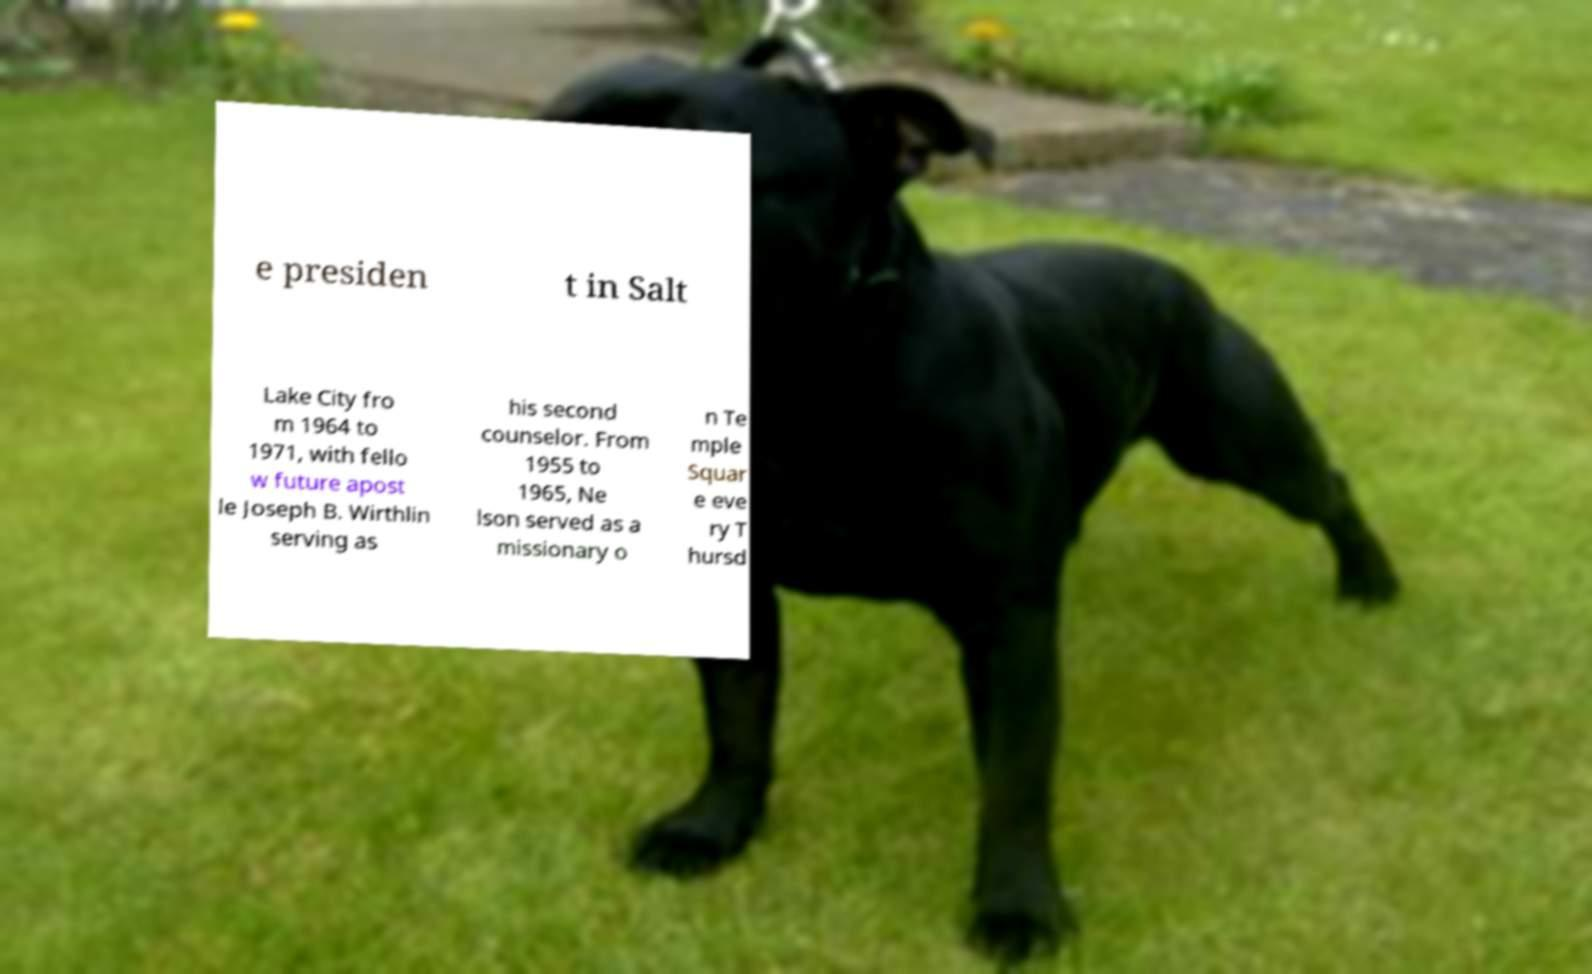What messages or text are displayed in this image? I need them in a readable, typed format. e presiden t in Salt Lake City fro m 1964 to 1971, with fello w future apost le Joseph B. Wirthlin serving as his second counselor. From 1955 to 1965, Ne lson served as a missionary o n Te mple Squar e eve ry T hursd 